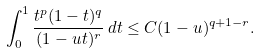<formula> <loc_0><loc_0><loc_500><loc_500>\int _ { 0 } ^ { 1 } \frac { t ^ { p } ( 1 - t ) ^ { q } } { ( 1 - u t ) ^ { r } } \, d t \leq C ( 1 - u ) ^ { q + 1 - r } .</formula> 